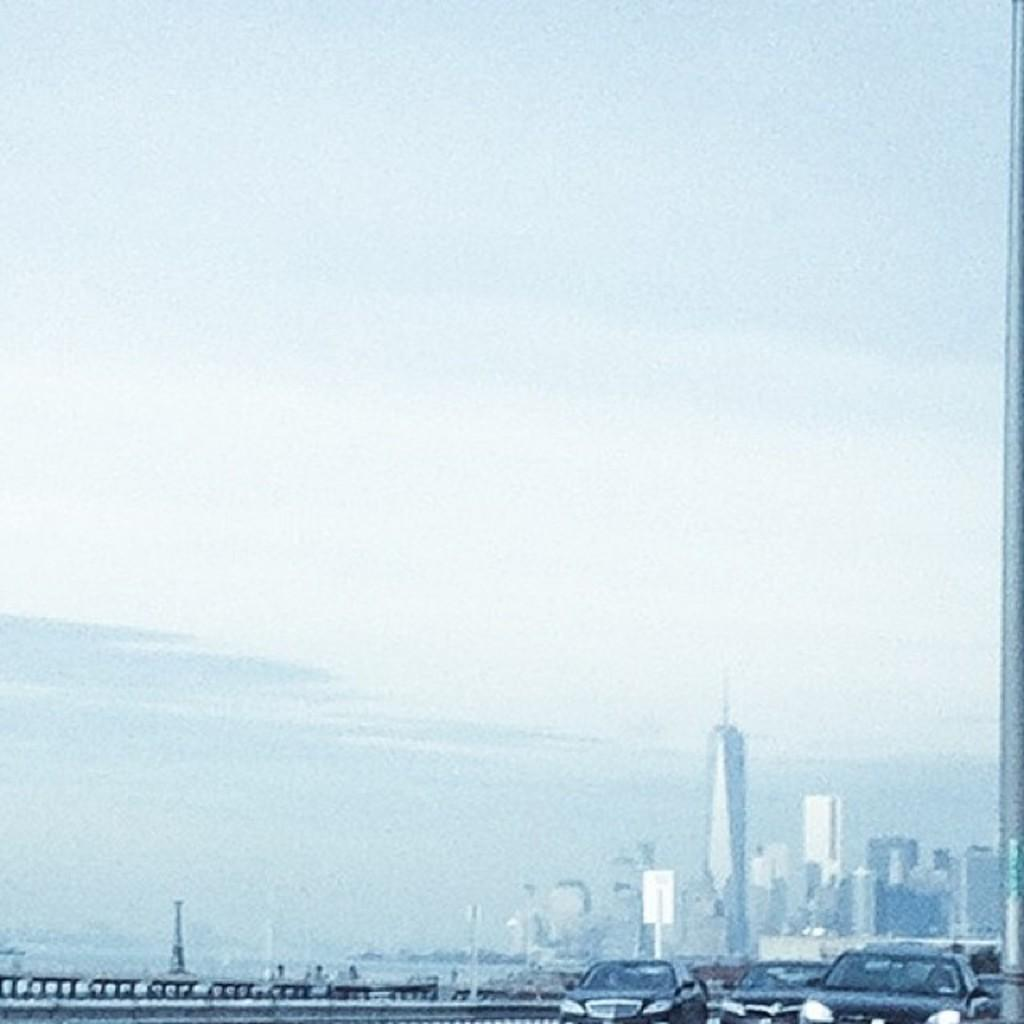What type of vehicles can be seen in the image? There are cars in the image. What structures are visible in the image? There are buildings in the image. What part of the natural environment is visible in the image? The sky is visible in the image. What can be seen in the sky? Clouds are present in the sky. Can you see a snake slithering on the seashore in the image? There is no seashore or snake present in the image. 